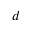Convert formula to latex. <formula><loc_0><loc_0><loc_500><loc_500>d</formula> 